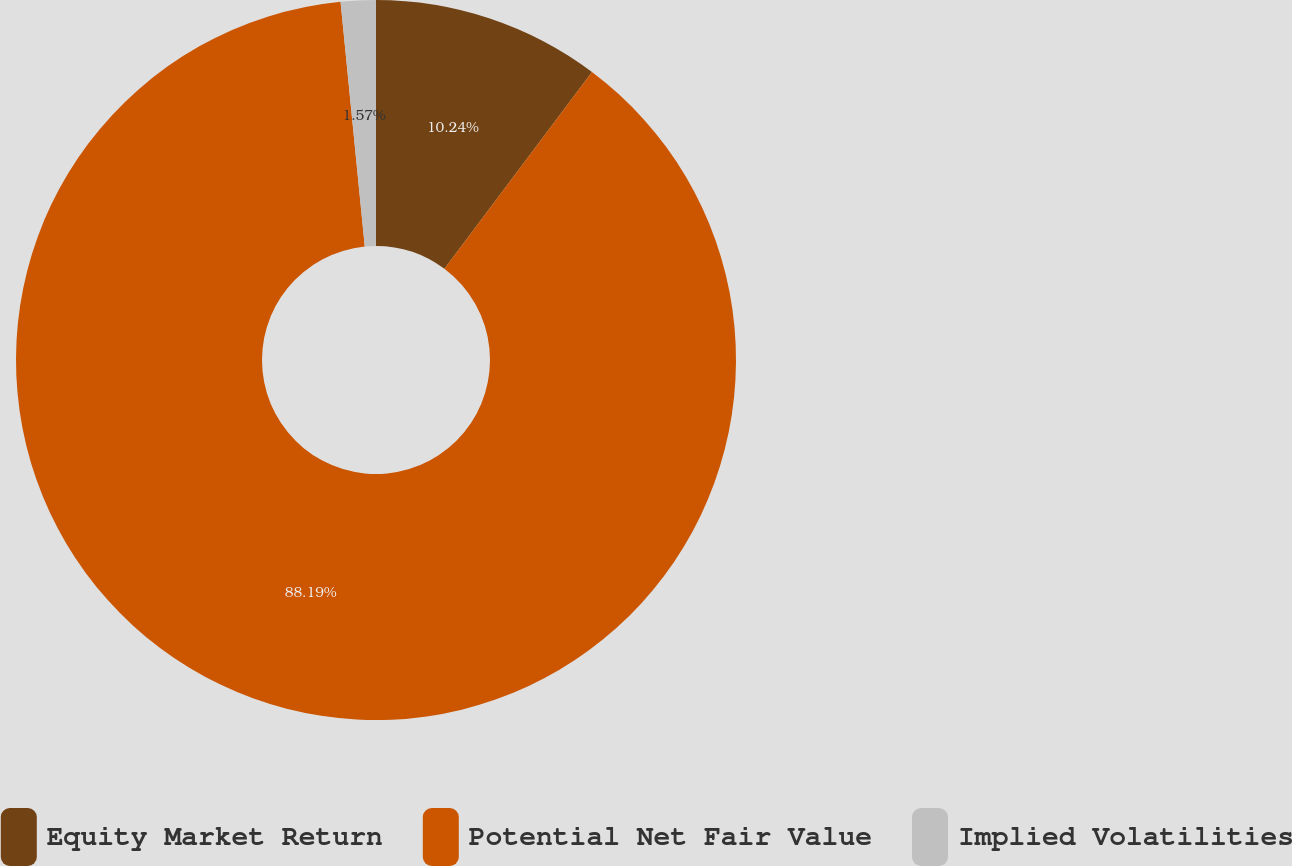Convert chart. <chart><loc_0><loc_0><loc_500><loc_500><pie_chart><fcel>Equity Market Return<fcel>Potential Net Fair Value<fcel>Implied Volatilities<nl><fcel>10.24%<fcel>88.19%<fcel>1.57%<nl></chart> 